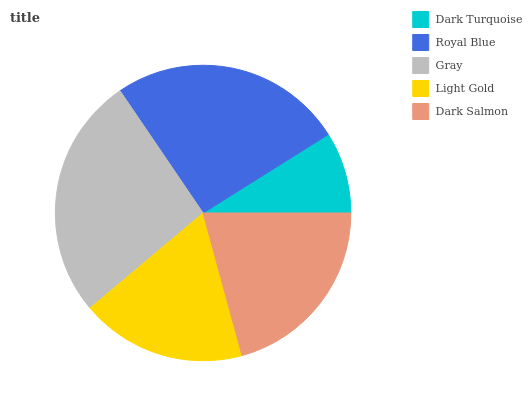Is Dark Turquoise the minimum?
Answer yes or no. Yes. Is Gray the maximum?
Answer yes or no. Yes. Is Royal Blue the minimum?
Answer yes or no. No. Is Royal Blue the maximum?
Answer yes or no. No. Is Royal Blue greater than Dark Turquoise?
Answer yes or no. Yes. Is Dark Turquoise less than Royal Blue?
Answer yes or no. Yes. Is Dark Turquoise greater than Royal Blue?
Answer yes or no. No. Is Royal Blue less than Dark Turquoise?
Answer yes or no. No. Is Dark Salmon the high median?
Answer yes or no. Yes. Is Dark Salmon the low median?
Answer yes or no. Yes. Is Light Gold the high median?
Answer yes or no. No. Is Gray the low median?
Answer yes or no. No. 